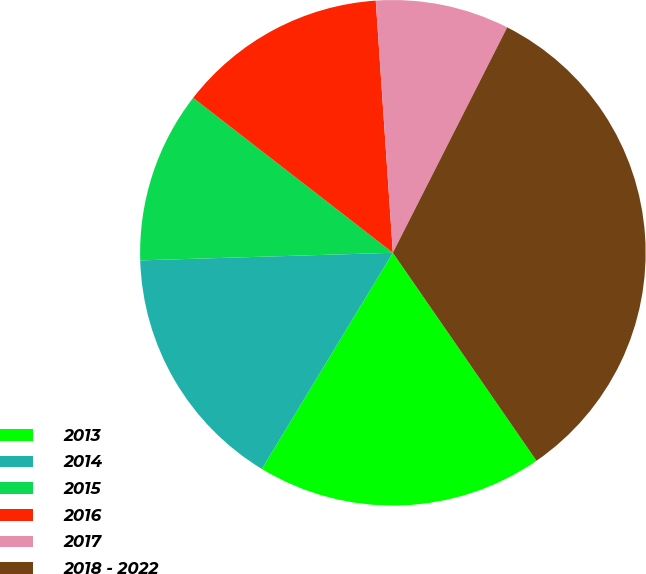<chart> <loc_0><loc_0><loc_500><loc_500><pie_chart><fcel>2013<fcel>2014<fcel>2015<fcel>2016<fcel>2017<fcel>2018 - 2022<nl><fcel>18.29%<fcel>15.85%<fcel>10.98%<fcel>13.42%<fcel>8.55%<fcel>32.91%<nl></chart> 